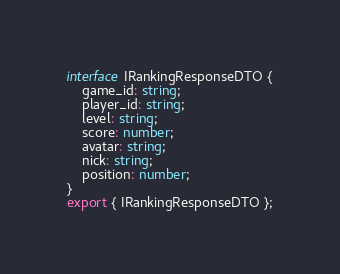Convert code to text. <code><loc_0><loc_0><loc_500><loc_500><_TypeScript_>interface IRankingResponseDTO {
	game_id: string;
	player_id: string;
	level: string;
	score: number;
	avatar: string;
	nick: string;
	position: number;
}
export { IRankingResponseDTO };
</code> 